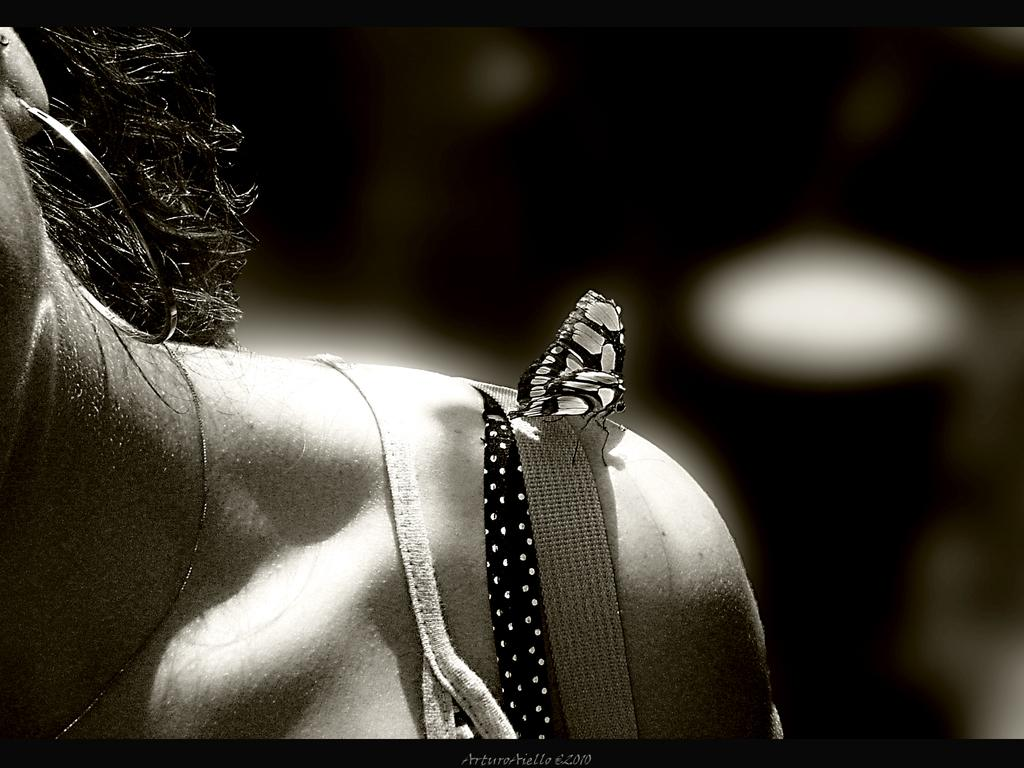What is the main subject of the image? The main subject of the image is a butterfly. Where is the butterfly located in the image? The butterfly is depicted on the shoulder of a woman. What direction is the butterfly facing in the image? The provided facts do not mention the direction the butterfly is facing, so it cannot be determined from the image. Is the butterfly in the pocket of the woman in the image? No, the butterfly is depicted on the shoulder of the woman, not in her pocket. 